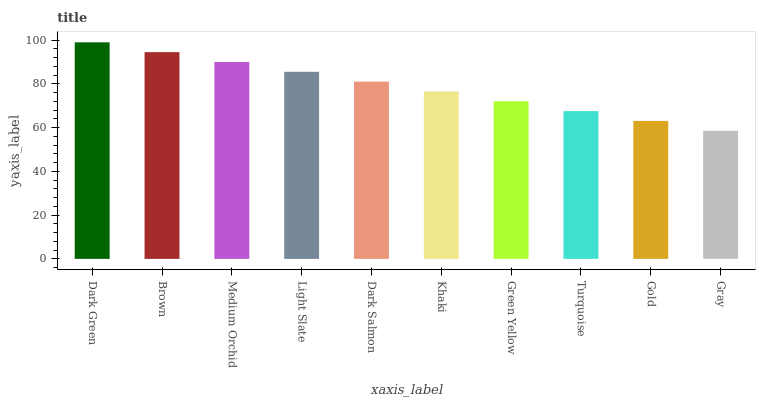Is Gray the minimum?
Answer yes or no. Yes. Is Dark Green the maximum?
Answer yes or no. Yes. Is Brown the minimum?
Answer yes or no. No. Is Brown the maximum?
Answer yes or no. No. Is Dark Green greater than Brown?
Answer yes or no. Yes. Is Brown less than Dark Green?
Answer yes or no. Yes. Is Brown greater than Dark Green?
Answer yes or no. No. Is Dark Green less than Brown?
Answer yes or no. No. Is Dark Salmon the high median?
Answer yes or no. Yes. Is Khaki the low median?
Answer yes or no. Yes. Is Khaki the high median?
Answer yes or no. No. Is Dark Salmon the low median?
Answer yes or no. No. 